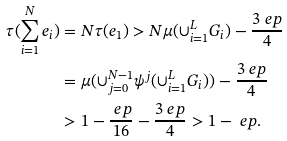<formula> <loc_0><loc_0><loc_500><loc_500>\tau ( \sum _ { i = 1 } ^ { N } e _ { i } ) & = N \tau ( e _ { 1 } ) > N \mu ( \cup _ { i = 1 } ^ { L } G _ { i } ) - \frac { 3 \ e p } { 4 } \\ & = \mu ( \cup _ { j = 0 } ^ { N - 1 } \psi ^ { j } ( \cup _ { i = 1 } ^ { L } G _ { i } ) ) - \frac { 3 \ e p } { 4 } \\ & > 1 - \frac { \ e p } { 1 6 } - \frac { 3 \ e p } { 4 } > 1 - \ e p .</formula> 